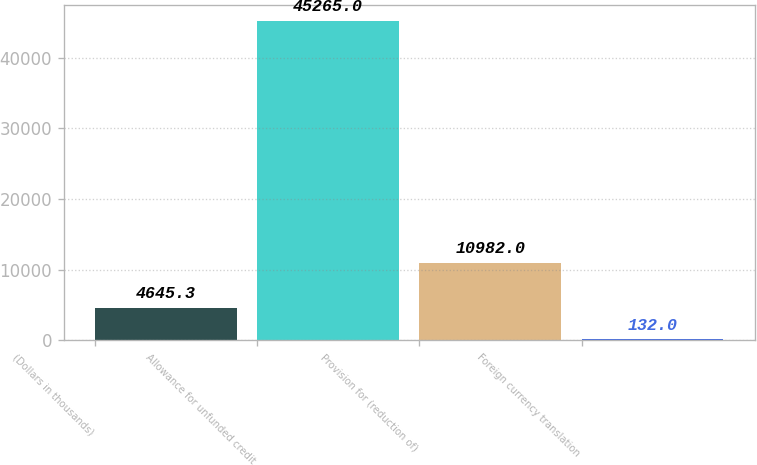Convert chart to OTSL. <chart><loc_0><loc_0><loc_500><loc_500><bar_chart><fcel>(Dollars in thousands)<fcel>Allowance for unfunded credit<fcel>Provision for (reduction of)<fcel>Foreign currency translation<nl><fcel>4645.3<fcel>45265<fcel>10982<fcel>132<nl></chart> 